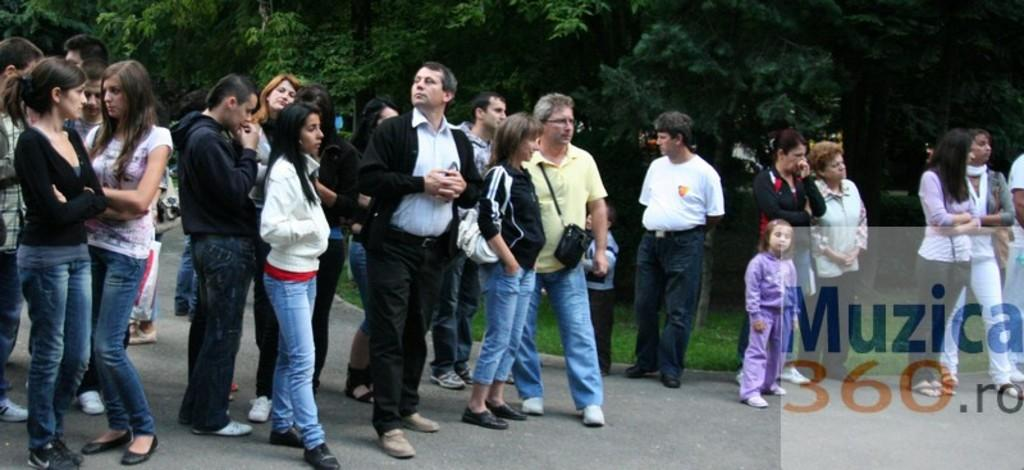Who or what can be seen in the image? There are people in the image. What are some people wearing in the image? Some people are wearing bags in the image. What can be seen in the distance in the image? There are trees in the background of the image. Is there any text visible in the image? Yes, there is some text visible in the image. What type of pies are being served at the feast depicted in the image? There is no feast or pies present in the image; it features people with bags and trees in the background. 